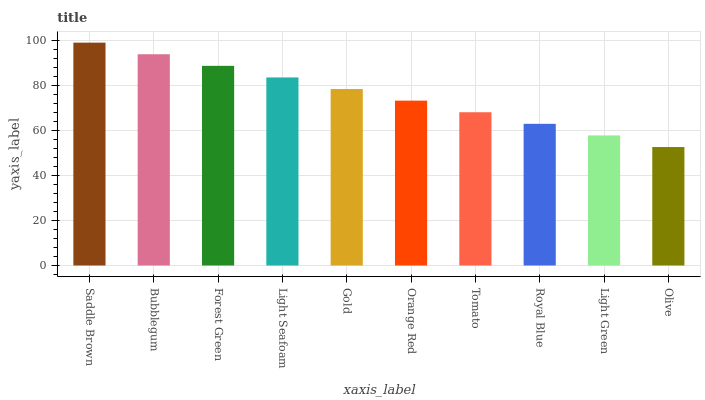Is Olive the minimum?
Answer yes or no. Yes. Is Saddle Brown the maximum?
Answer yes or no. Yes. Is Bubblegum the minimum?
Answer yes or no. No. Is Bubblegum the maximum?
Answer yes or no. No. Is Saddle Brown greater than Bubblegum?
Answer yes or no. Yes. Is Bubblegum less than Saddle Brown?
Answer yes or no. Yes. Is Bubblegum greater than Saddle Brown?
Answer yes or no. No. Is Saddle Brown less than Bubblegum?
Answer yes or no. No. Is Gold the high median?
Answer yes or no. Yes. Is Orange Red the low median?
Answer yes or no. Yes. Is Orange Red the high median?
Answer yes or no. No. Is Olive the low median?
Answer yes or no. No. 